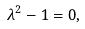<formula> <loc_0><loc_0><loc_500><loc_500>\lambda ^ { 2 } - 1 = 0 ,</formula> 